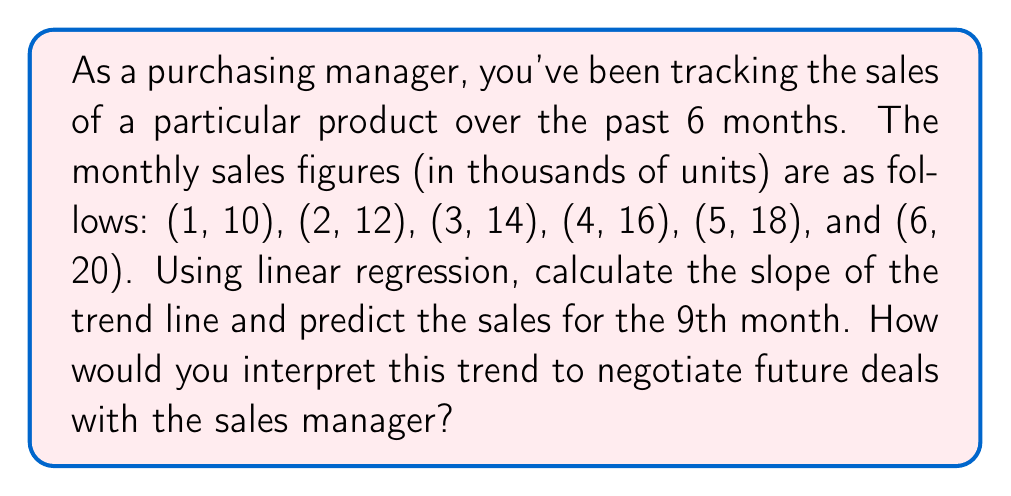Provide a solution to this math problem. To solve this problem, we'll use linear regression to find the slope and y-intercept of the trend line, then use this information to predict future sales.

1. Calculate the slope using the linear regression formula:

   $$m = \frac{n\sum xy - \sum x \sum y}{n\sum x^2 - (\sum x)^2}$$

   Where:
   $n$ = number of data points = 6
   $\sum x = 1 + 2 + 3 + 4 + 5 + 6 = 21$
   $\sum y = 10 + 12 + 14 + 16 + 18 + 20 = 90$
   $\sum xy = 1(10) + 2(12) + 3(14) + 4(16) + 5(18) + 6(20) = 350$
   $\sum x^2 = 1^2 + 2^2 + 3^2 + 4^2 + 5^2 + 6^2 = 91$

   Plugging in these values:

   $$m = \frac{6(350) - 21(90)}{6(91) - 21^2} = \frac{2100 - 1890}{546 - 441} = \frac{210}{105} = 2$$

2. Calculate the y-intercept using the formula:

   $$b = \frac{\sum y - m\sum x}{n}$$

   $$b = \frac{90 - 2(21)}{6} = \frac{90 - 42}{6} = 8$$

3. The equation of the trend line is:

   $$y = 2x + 8$$

4. To predict sales for the 9th month, substitute $x = 9$:

   $$y = 2(9) + 8 = 26$$

Interpretation: The slope of 2 indicates that sales are increasing by 2,000 units each month. The y-intercept of 8 suggests that if this trend were to be extrapolated back to the beginning (month 0), the baseline sales would be 8,000 units. The prediction for the 9th month is 26,000 units.

As a purchasing manager, you could use this information to negotiate future deals by:
1. Anticipating increased demand and potentially securing bulk discounts.
2. Discussing long-term contracts that account for the steady growth in sales.
3. Negotiating tiered pricing based on the projected sales increases.
4. Planning inventory and supply chain adjustments to accommodate the growth trend.
Answer: Slope of trend line: 2
Predicted sales for 9th month: 26,000 units 